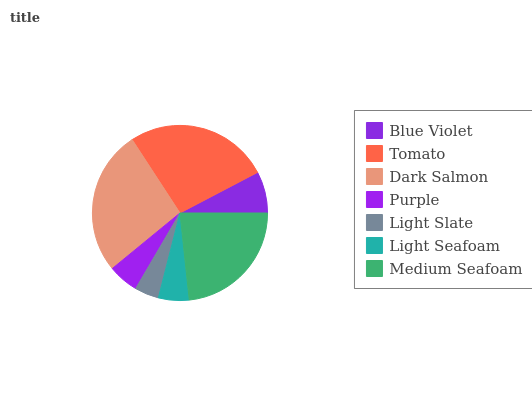Is Light Slate the minimum?
Answer yes or no. Yes. Is Dark Salmon the maximum?
Answer yes or no. Yes. Is Tomato the minimum?
Answer yes or no. No. Is Tomato the maximum?
Answer yes or no. No. Is Tomato greater than Blue Violet?
Answer yes or no. Yes. Is Blue Violet less than Tomato?
Answer yes or no. Yes. Is Blue Violet greater than Tomato?
Answer yes or no. No. Is Tomato less than Blue Violet?
Answer yes or no. No. Is Blue Violet the high median?
Answer yes or no. Yes. Is Blue Violet the low median?
Answer yes or no. Yes. Is Purple the high median?
Answer yes or no. No. Is Light Slate the low median?
Answer yes or no. No. 